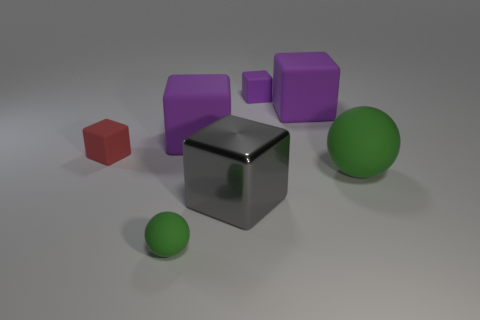Do the small sphere and the big sphere have the same color? Yes, both the small sphere and the big sphere share the same hue of green. It's interesting to note that even though they are the same color, their sizes might make them appear slightly different due to how light and shadow play on their surfaces. 